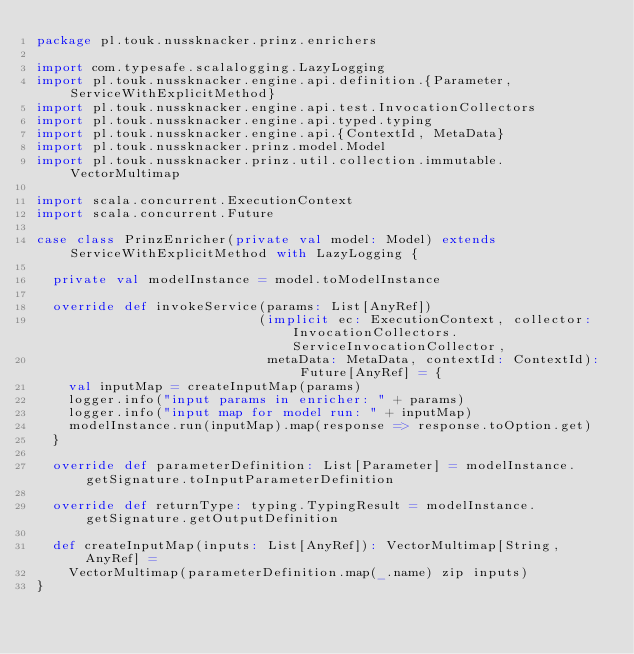Convert code to text. <code><loc_0><loc_0><loc_500><loc_500><_Scala_>package pl.touk.nussknacker.prinz.enrichers

import com.typesafe.scalalogging.LazyLogging
import pl.touk.nussknacker.engine.api.definition.{Parameter, ServiceWithExplicitMethod}
import pl.touk.nussknacker.engine.api.test.InvocationCollectors
import pl.touk.nussknacker.engine.api.typed.typing
import pl.touk.nussknacker.engine.api.{ContextId, MetaData}
import pl.touk.nussknacker.prinz.model.Model
import pl.touk.nussknacker.prinz.util.collection.immutable.VectorMultimap

import scala.concurrent.ExecutionContext
import scala.concurrent.Future

case class PrinzEnricher(private val model: Model) extends ServiceWithExplicitMethod with LazyLogging {

  private val modelInstance = model.toModelInstance

  override def invokeService(params: List[AnyRef])
                            (implicit ec: ExecutionContext, collector: InvocationCollectors.ServiceInvocationCollector,
                             metaData: MetaData, contextId: ContextId): Future[AnyRef] = {
    val inputMap = createInputMap(params)
    logger.info("input params in enricher: " + params)
    logger.info("input map for model run: " + inputMap)
    modelInstance.run(inputMap).map(response => response.toOption.get)
  }

  override def parameterDefinition: List[Parameter] = modelInstance.getSignature.toInputParameterDefinition

  override def returnType: typing.TypingResult = modelInstance.getSignature.getOutputDefinition

  def createInputMap(inputs: List[AnyRef]): VectorMultimap[String, AnyRef] =
    VectorMultimap(parameterDefinition.map(_.name) zip inputs)
}
</code> 